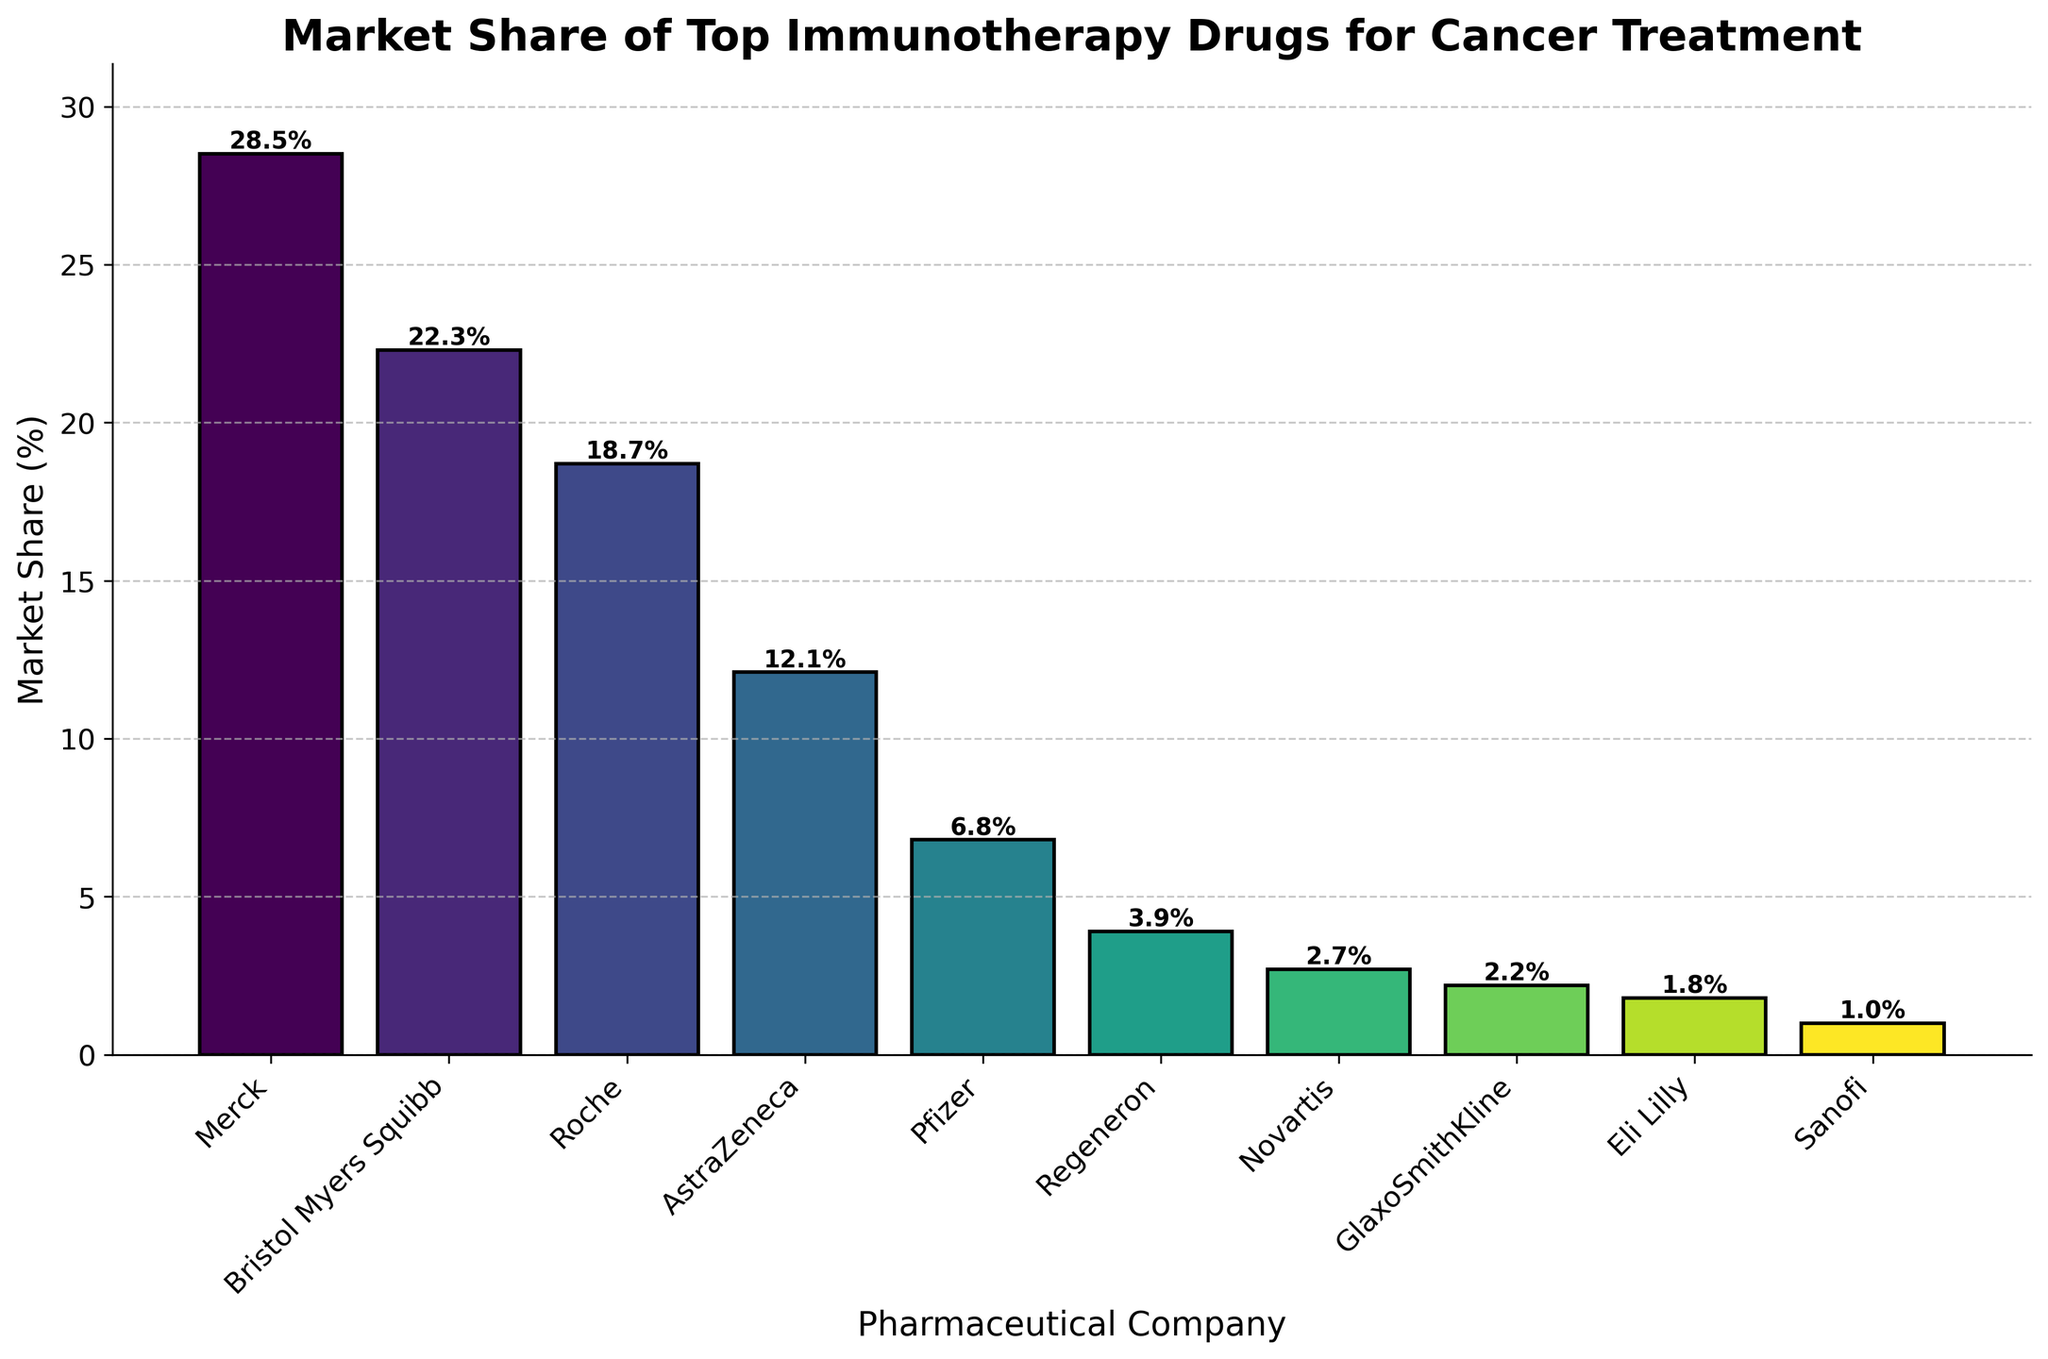What is the market share of the company with the highest market share? The bar for Merck is the tallest, indicating it has the highest market share. The text atop the Merck bar reads 28.5%.
Answer: 28.5% Which company has a higher market share, Roche or AstraZeneca? The bars show Roche and AstraZeneca next to each other, with the height of Roche’s bar being greater. The Roche bar is labeled 18.7%, and the AstraZeneca bar is labeled 12.1%.
Answer: Roche What is the difference in market share between Pfizer and Regeneron? The height of Pfizer's bar is labeled 6.8%, while Regeneron's bar is labeled 3.9%. The difference between these percentages is 6.8% - 3.9% = 2.9%.
Answer: 2.9% Which company is represented by the lightest color in the bar chart, and what is its market share? From the color gradient, the lightest bar is the one for Sanofi. The text atop this bar reads 1.0%.
Answer: Sanofi, 1.0% Which companies have a market share greater than 10%? The bars with heights above 10% belong to Merck, Bristol Myers Squibb, Roche, and AstraZeneca. Their respective labels are above 10%.
Answer: Merck, Bristol Myers Squibb, Roche, AstraZeneca What is the combined market share of Merck and Bristol Myers Squibb? Adding the market shares for Merck (28.5%) and Bristol Myers Squibb (22.3%) gives 28.5% + 22.3% = 50.8%.
Answer: 50.8% How many companies have a market share less than 5%? By examining the bars less than halfway up the y-axis (label for 5%), the companies are Regeneron, Novartis, GlaxoSmithKline, Eli Lilly, and Sanofi, totalling 5 companies.
Answer: 5 Subtract the market share of Roche from the market share of the company with the highest value in the chart. The market share for Merck is 28.5%, and for Roche is 18.7%. The difference is 28.5% - 18.7% = 9.8%.
Answer: 9.8% What is the average market share of all the companies listed in the chart? Summing up all market share values: 28.5% + 22.3% + 18.7% + 12.1% + 6.8% + 3.9% + 2.7% + 2.2% + 1.8% + 1.0% = 100%. Dividing by 10 companies, the average is 100% / 10 = 10%.
Answer: 10% What is the ratio of the market share of Merck to the market share of Pfizer? The market share of Merck is 28.5%, and Pfizer is 6.8%. The ratio is 28.5 / 6.8, which simplifies to approximately 4.2.
Answer: 4.2 